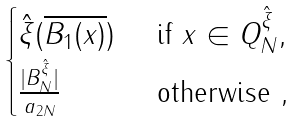Convert formula to latex. <formula><loc_0><loc_0><loc_500><loc_500>\begin{cases} { \hat { \xi } } ( \overline { B _ { 1 } ( x ) } ) & \text { if } x \in Q _ { N } ^ { \hat { \xi } } , \\ \frac { | B _ { N } ^ { \hat { \xi } } | } { a _ { 2 N } } & \text { otherwise } , \end{cases}</formula> 